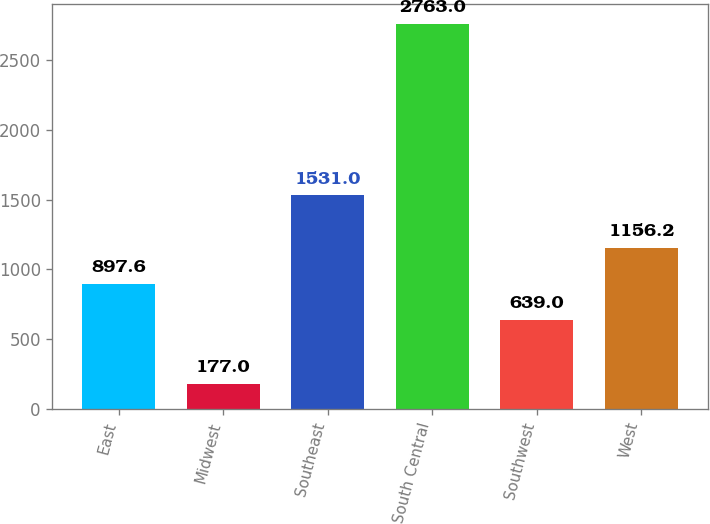Convert chart to OTSL. <chart><loc_0><loc_0><loc_500><loc_500><bar_chart><fcel>East<fcel>Midwest<fcel>Southeast<fcel>South Central<fcel>Southwest<fcel>West<nl><fcel>897.6<fcel>177<fcel>1531<fcel>2763<fcel>639<fcel>1156.2<nl></chart> 